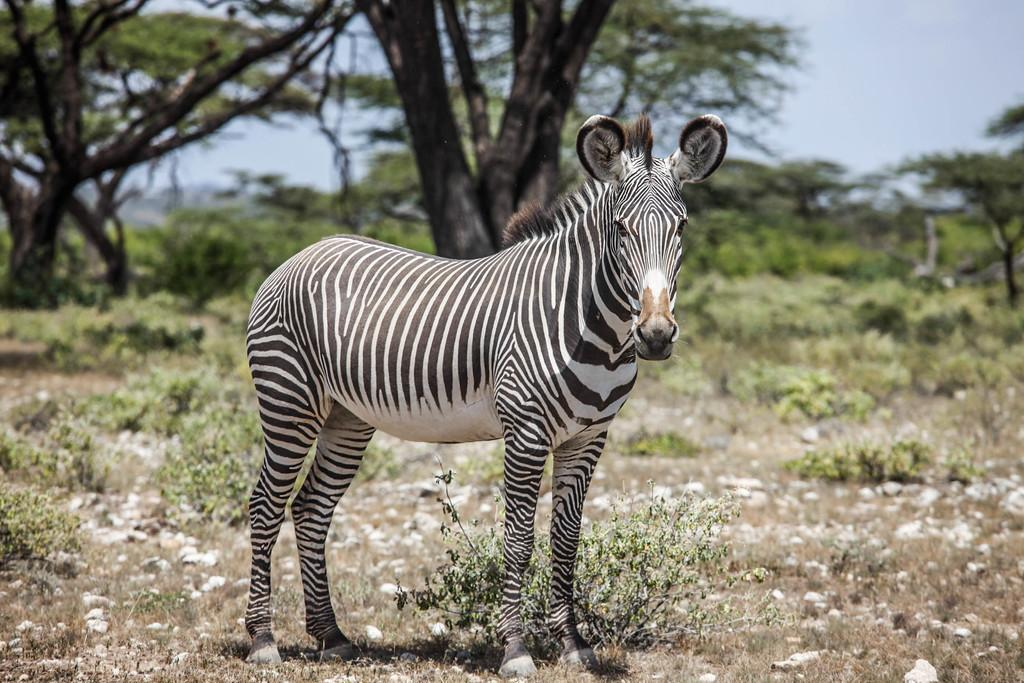Where was the image taken? The image was clicked outside. What type of vegetation can be seen at the bottom of the image? There are small plants at the bottom of the image. What type of vegetation can be seen at the top of the image? There are trees at the top of the image. What is visible at the top of the image? The sky is visible at the top of the image. What animal is standing in the middle of the image? There is a zebra standing in the middle of the image. What type of whistle is the zebra using to communicate with the birds in the image? There are no birds present in the image, and the zebra is not using a whistle to communicate. 